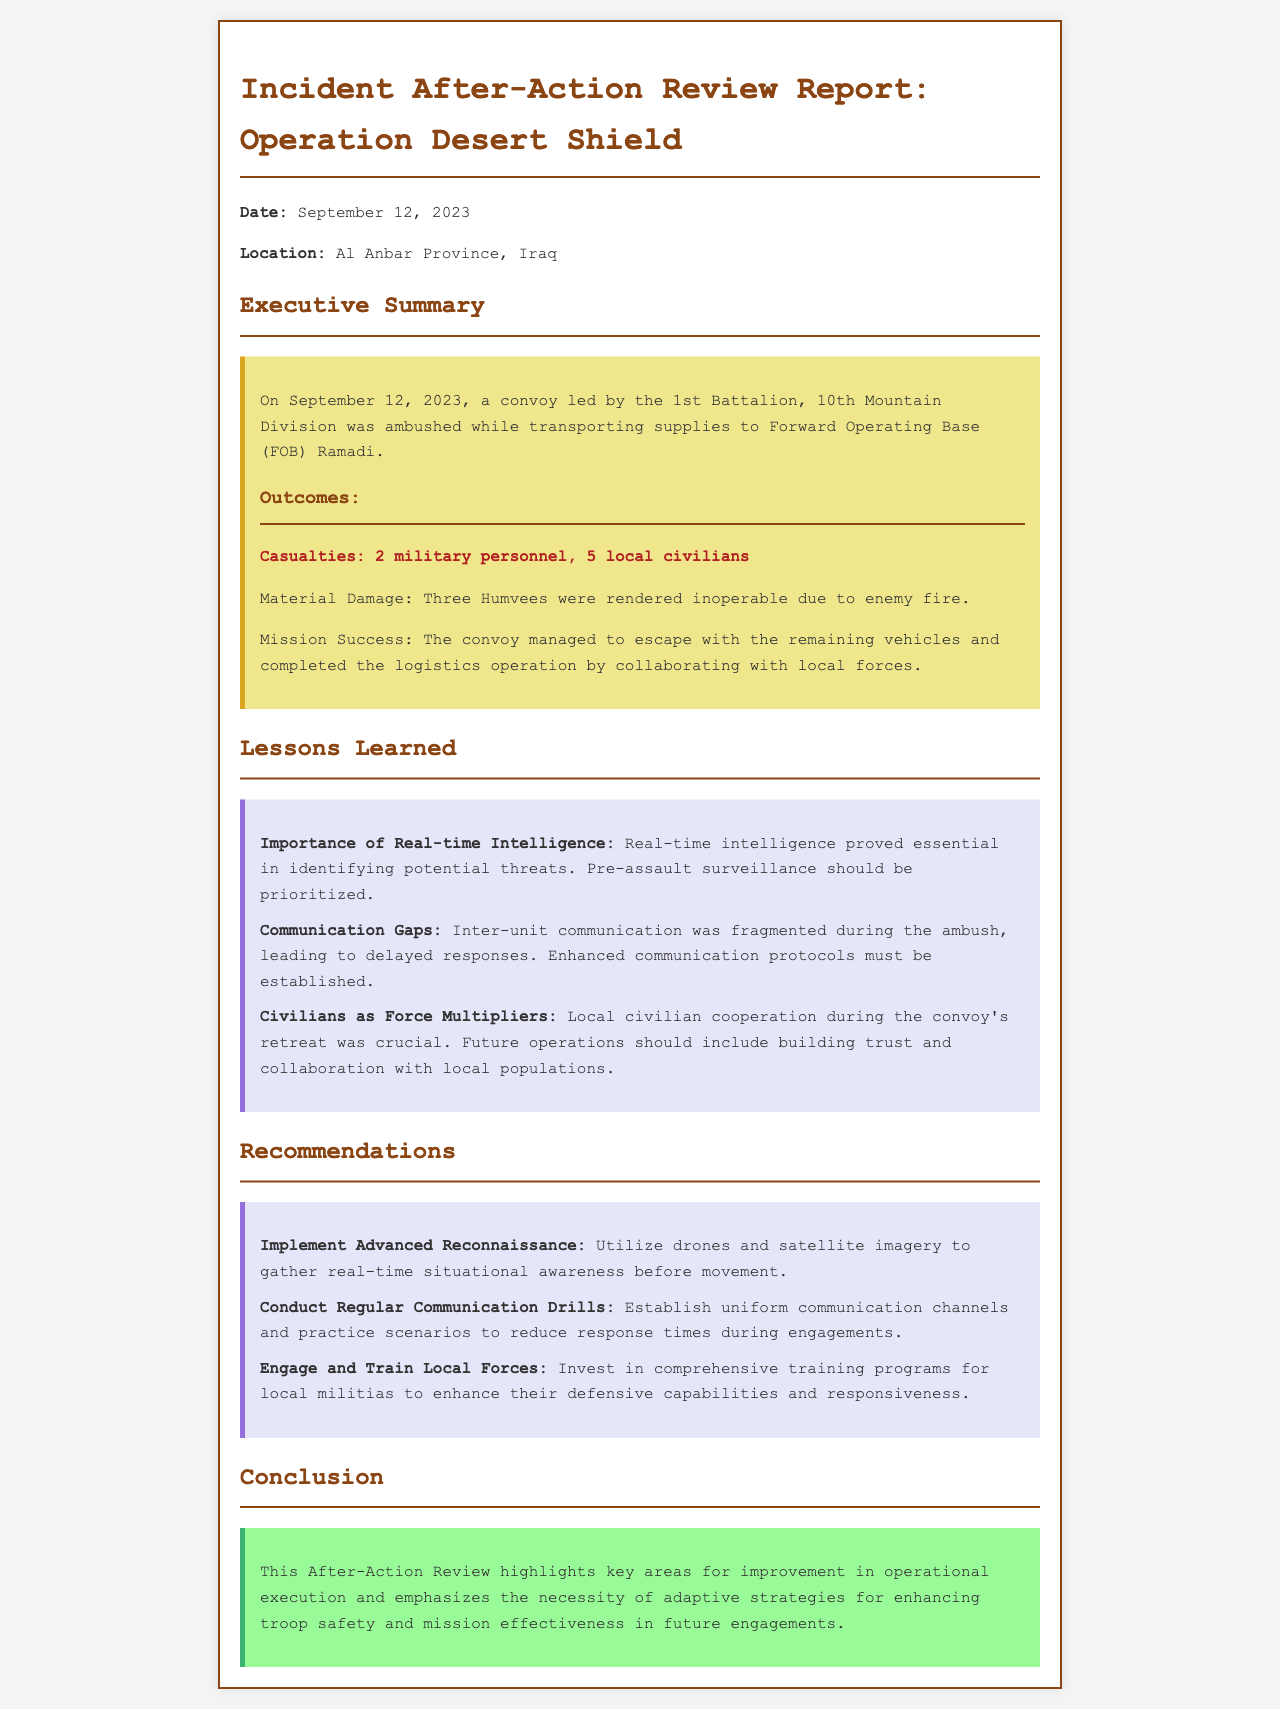What was the date of the incident? The date of the incident is explicitly mentioned in the report as September 12, 2023.
Answer: September 12, 2023 How many local civilians were casualties? The report states that there were 5 local civilians who were casualties during the incident.
Answer: 5 local civilians What was the primary mission of the convoy? The convoy's mission was to transport supplies to Forward Operating Base (FOB) Ramadi, as stated in the executive summary.
Answer: Transporting supplies to FOB Ramadi What is one lesson learned related to communication? One lesson learned highlights that inter-unit communication was fragmented during the ambush, indicating a need for enhanced protocols.
Answer: Communication Gaps What is one recommendation for improving reconnaissance? The report recommends implementing advanced reconnaissance utilizing drones and satellite imagery for better situational awareness.
Answer: Utilize drones and satellite imagery How many Humvees were rendered inoperable? The report specifies that three Humvees were rendered inoperable due to enemy fire in the aftermath of the ambush.
Answer: Three Humvees What role did local civilians play during the incident? Local civilians cooperated during the convoy's retreat, proving to be crucial in the operation as per the lessons learned.
Answer: Crucial cooperation What was the outcome regarding mission success? The report states that the convoy managed to escape with the remaining vehicles and completed its logistics operation, indicating mission success.
Answer: Completed the logistics operation What background color denotes the recommendations section? The recommendations section is distinguished by a light lavender color, as indicated in the HTML styling of the document.
Answer: Light lavender 